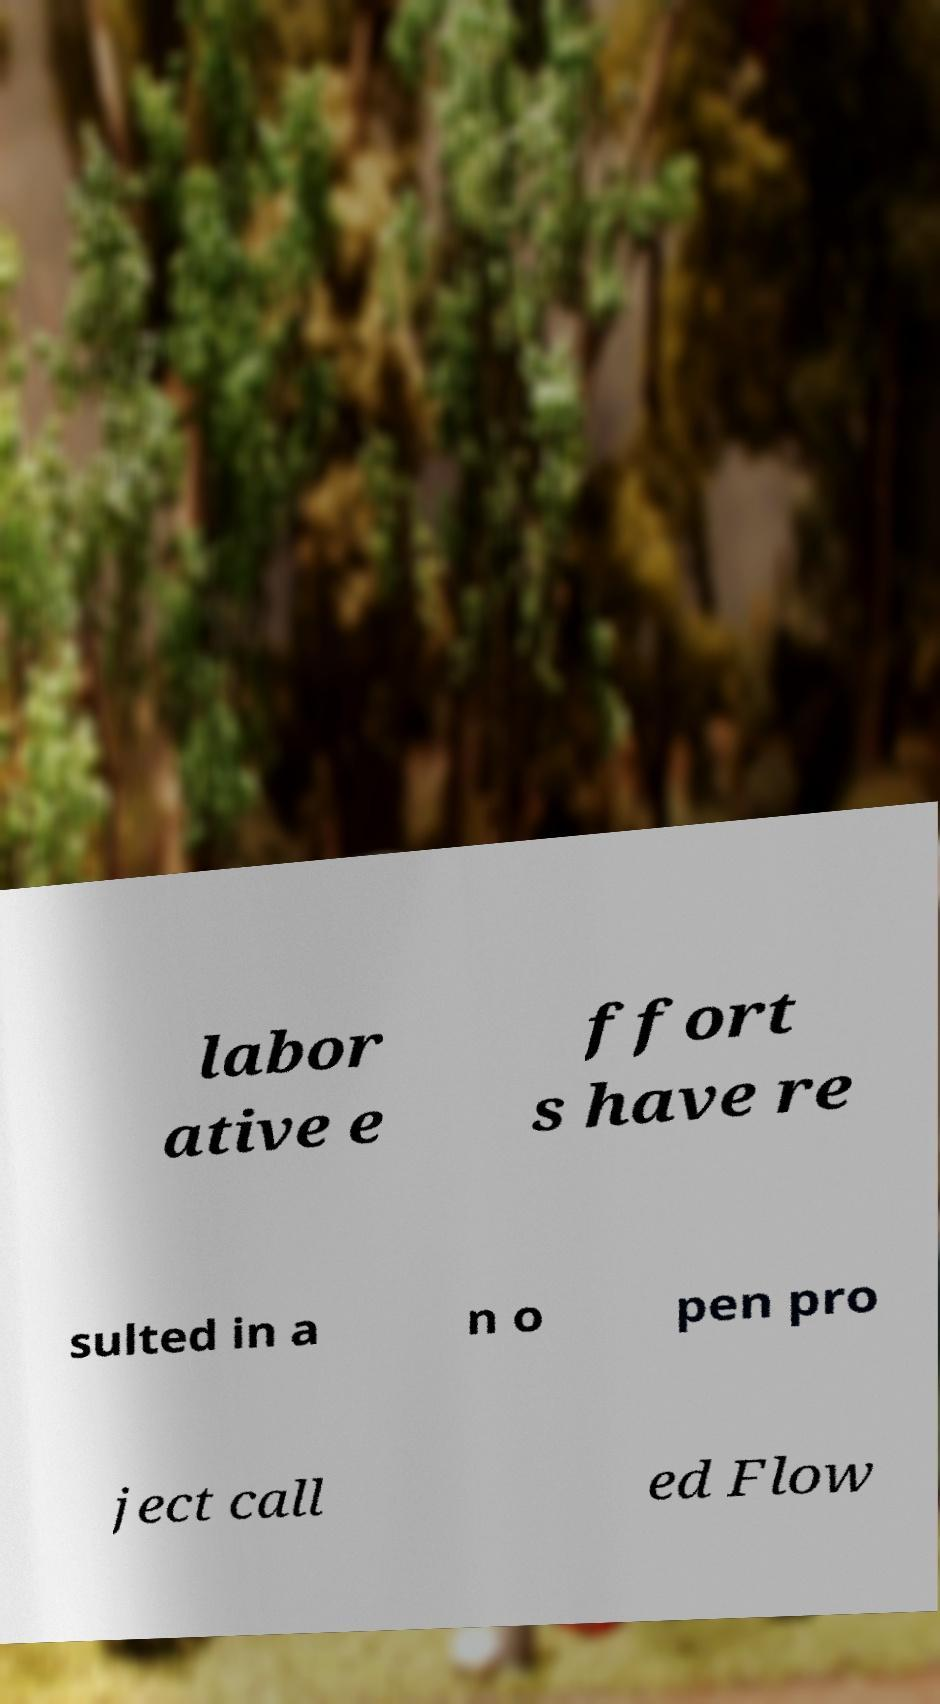There's text embedded in this image that I need extracted. Can you transcribe it verbatim? labor ative e ffort s have re sulted in a n o pen pro ject call ed Flow 